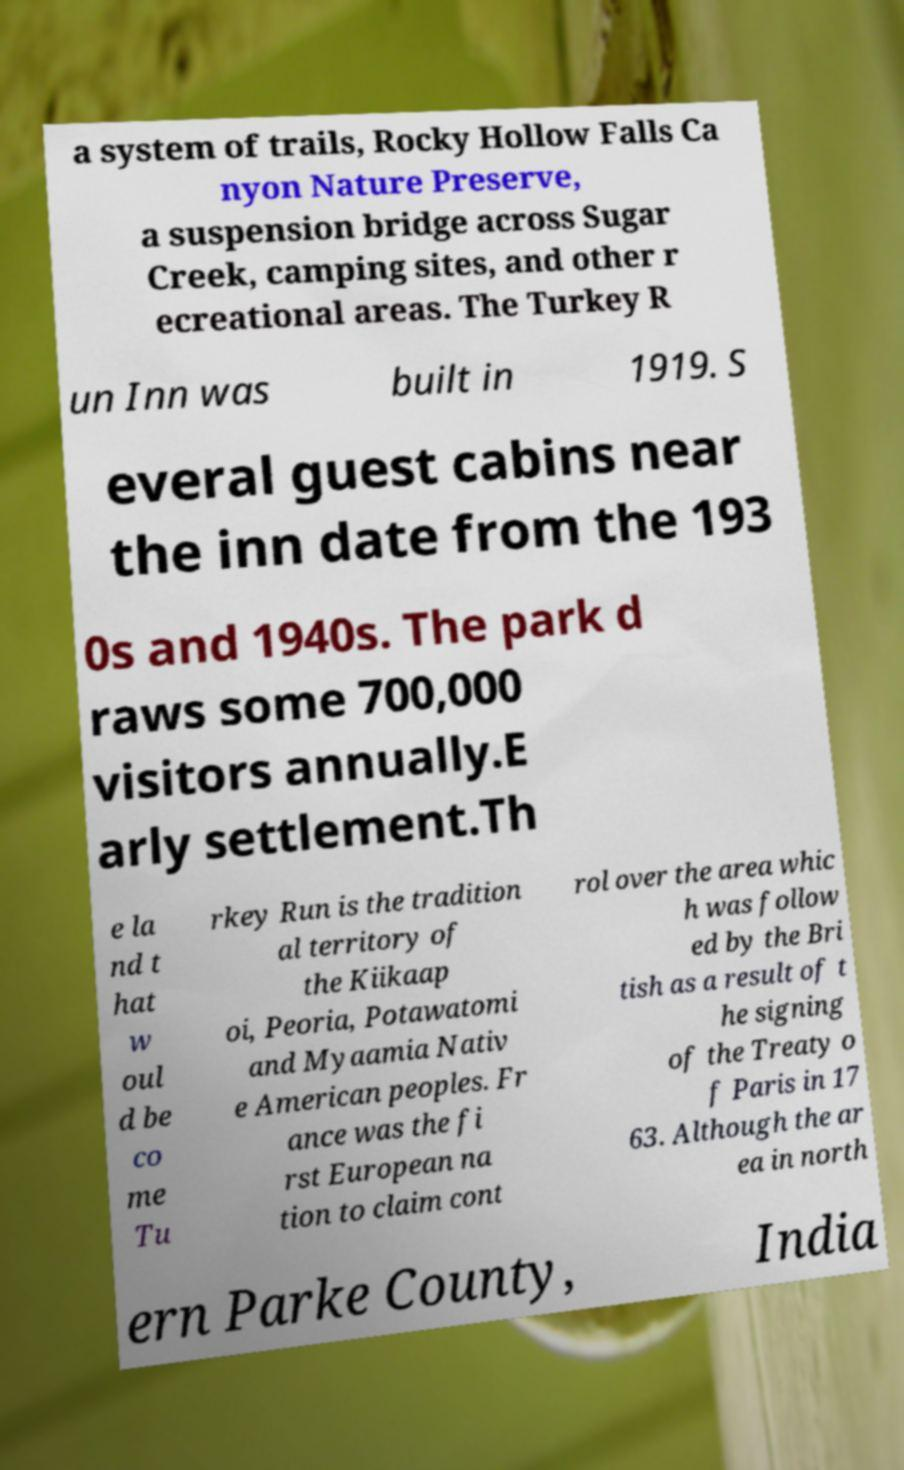Please read and relay the text visible in this image. What does it say? a system of trails, Rocky Hollow Falls Ca nyon Nature Preserve, a suspension bridge across Sugar Creek, camping sites, and other r ecreational areas. The Turkey R un Inn was built in 1919. S everal guest cabins near the inn date from the 193 0s and 1940s. The park d raws some 700,000 visitors annually.E arly settlement.Th e la nd t hat w oul d be co me Tu rkey Run is the tradition al territory of the Kiikaap oi, Peoria, Potawatomi and Myaamia Nativ e American peoples. Fr ance was the fi rst European na tion to claim cont rol over the area whic h was follow ed by the Bri tish as a result of t he signing of the Treaty o f Paris in 17 63. Although the ar ea in north ern Parke County, India 